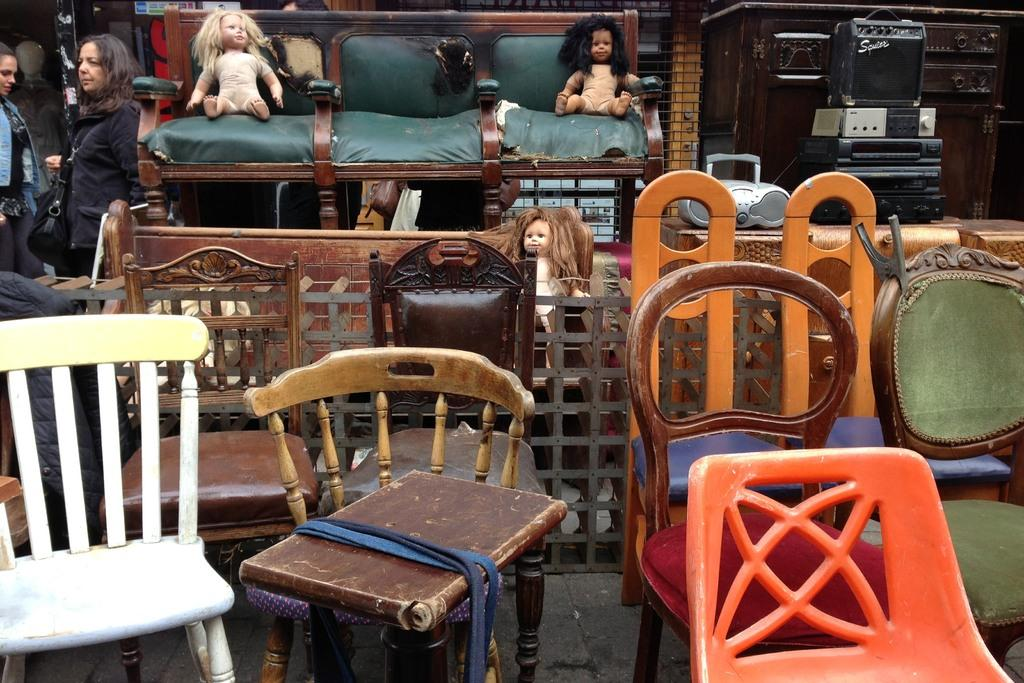What type of items are being sold on the road? There is old furniture for sale on the road. Can you describe some specific pieces of furniture? There are chairs and a sofa among the furniture. Are there any other items mixed with the furniture? Yes, there are dolls and a music system with speakers among the furniture. What is happening around the furniture? People are passing by the furniture. How many pizzas are being sold with the furniture in the image? There are no pizzas being sold with the furniture in the image; it only features old furniture, chairs, a sofa, dolls, and a music system with speakers. Can you tell me how many people are sleeping on the furniture in the image? There are no people sleeping on the furniture in the image; people are only passing by. 